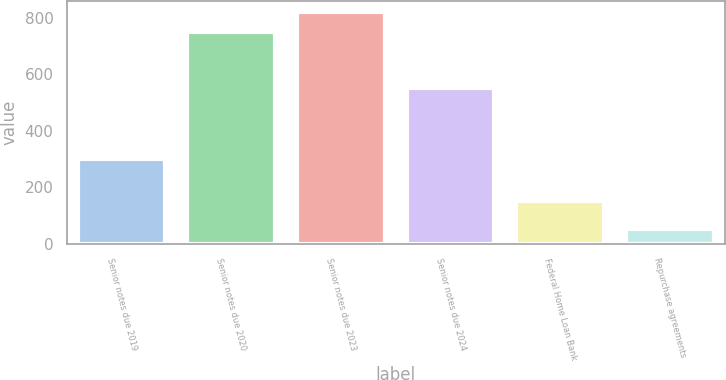Convert chart. <chart><loc_0><loc_0><loc_500><loc_500><bar_chart><fcel>Senior notes due 2019<fcel>Senior notes due 2020<fcel>Senior notes due 2023<fcel>Senior notes due 2024<fcel>Federal Home Loan Bank<fcel>Repurchase agreements<nl><fcel>300<fcel>750<fcel>820<fcel>550<fcel>150<fcel>50<nl></chart> 